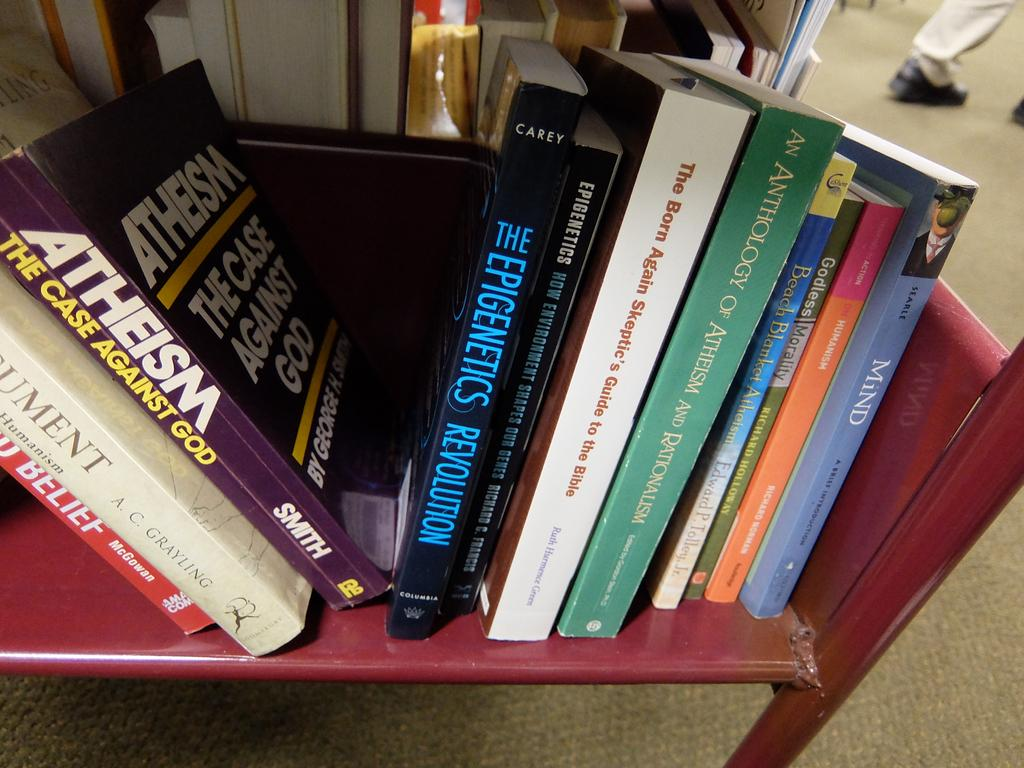<image>
Summarize the visual content of the image. Books on a shelf including one that says ATHEISM. 